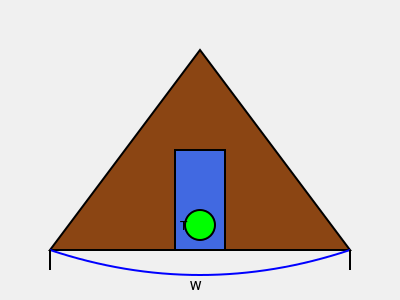In the 3D visualization of a hydroelectric dam, the turbine (T) is positioned at the base of the dam. If the width (W) of the dam is 300 meters and the height (H) is 200 meters, what is the optimal depth (D) of the turbine placement from the water surface to maximize energy generation while minimizing environmental impact? To determine the optimal depth (D) of the turbine placement, we need to consider several factors:

1. Hydraulic head: The difference in height between the water surface and the turbine. A greater head generally leads to more power generation.

2. Environmental impact: Placing the turbine too deep might affect aquatic life and sediment flow.

3. Dam stability: The turbine should not compromise the structural integrity of the dam.

4. Water pressure: The pressure increases with depth, affecting turbine efficiency and durability.

5. Cost-effectiveness: Deeper placement increases construction costs.

Considering these factors, a general rule of thumb in hydroelectric dam design is to place the turbine at approximately 2/3 of the total dam height from the water surface. This placement provides a good balance between energy generation and environmental considerations.

Calculation:
1. Total dam height (H) = 200 meters
2. Optimal depth (D) = $\frac{2}{3} \times H$
3. D = $\frac{2}{3} \times 200$ meters
4. D = 133.33 meters

Rounding to the nearest meter for practical purposes, the optimal depth is 133 meters.

This depth allows for significant hydraulic head while leaving some water at the bottom of the reservoir, which helps maintain aquatic ecosystems and allows for sediment management.
Answer: 133 meters 